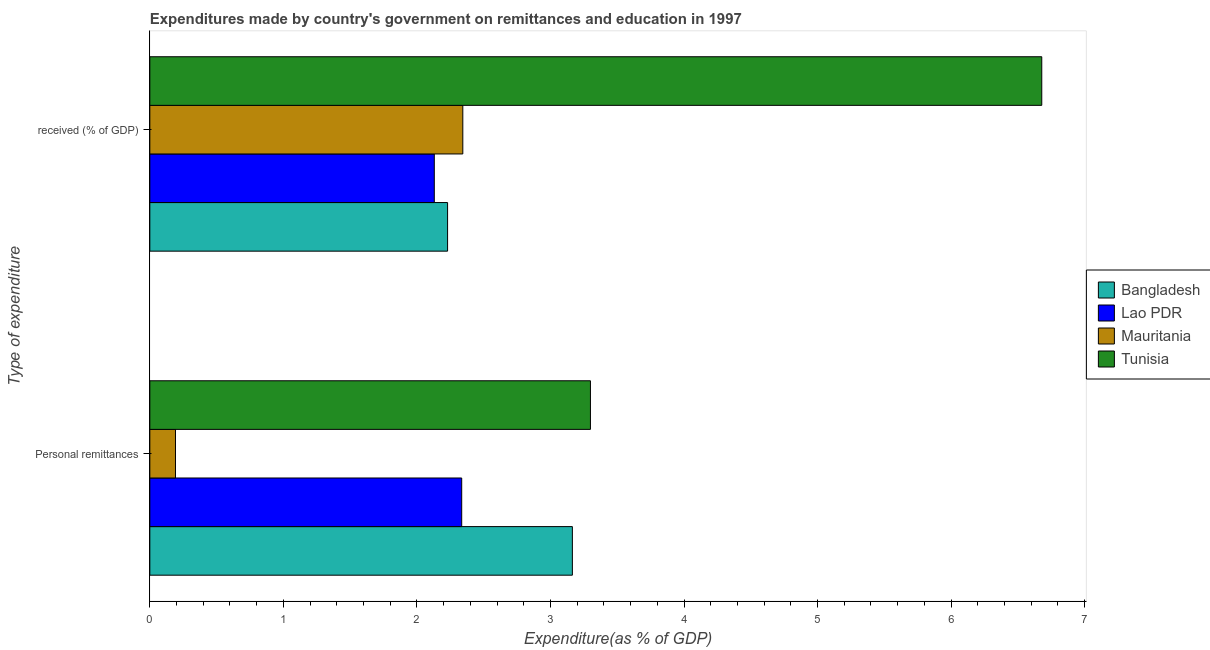Are the number of bars per tick equal to the number of legend labels?
Ensure brevity in your answer.  Yes. Are the number of bars on each tick of the Y-axis equal?
Your response must be concise. Yes. How many bars are there on the 2nd tick from the bottom?
Offer a very short reply. 4. What is the label of the 2nd group of bars from the top?
Offer a terse response. Personal remittances. What is the expenditure in education in Lao PDR?
Your response must be concise. 2.13. Across all countries, what is the maximum expenditure in personal remittances?
Make the answer very short. 3.3. Across all countries, what is the minimum expenditure in education?
Make the answer very short. 2.13. In which country was the expenditure in education maximum?
Provide a succinct answer. Tunisia. In which country was the expenditure in education minimum?
Your answer should be compact. Lao PDR. What is the total expenditure in education in the graph?
Ensure brevity in your answer.  13.38. What is the difference between the expenditure in education in Bangladesh and that in Mauritania?
Give a very brief answer. -0.11. What is the difference between the expenditure in personal remittances in Mauritania and the expenditure in education in Bangladesh?
Offer a terse response. -2.04. What is the average expenditure in education per country?
Offer a very short reply. 3.35. What is the difference between the expenditure in personal remittances and expenditure in education in Mauritania?
Provide a succinct answer. -2.15. What is the ratio of the expenditure in personal remittances in Tunisia to that in Mauritania?
Your answer should be compact. 17.17. Is the expenditure in education in Lao PDR less than that in Bangladesh?
Provide a succinct answer. Yes. In how many countries, is the expenditure in education greater than the average expenditure in education taken over all countries?
Your response must be concise. 1. What does the 2nd bar from the top in Personal remittances represents?
Your response must be concise. Mauritania. What does the 3rd bar from the bottom in  received (% of GDP) represents?
Provide a succinct answer. Mauritania. Are all the bars in the graph horizontal?
Ensure brevity in your answer.  Yes. How many countries are there in the graph?
Ensure brevity in your answer.  4. What is the difference between two consecutive major ticks on the X-axis?
Offer a terse response. 1. Does the graph contain any zero values?
Offer a very short reply. No. Does the graph contain grids?
Provide a succinct answer. No. Where does the legend appear in the graph?
Give a very brief answer. Center right. How are the legend labels stacked?
Your answer should be compact. Vertical. What is the title of the graph?
Provide a succinct answer. Expenditures made by country's government on remittances and education in 1997. What is the label or title of the X-axis?
Your answer should be compact. Expenditure(as % of GDP). What is the label or title of the Y-axis?
Provide a succinct answer. Type of expenditure. What is the Expenditure(as % of GDP) in Bangladesh in Personal remittances?
Offer a terse response. 3.16. What is the Expenditure(as % of GDP) of Lao PDR in Personal remittances?
Keep it short and to the point. 2.34. What is the Expenditure(as % of GDP) of Mauritania in Personal remittances?
Your answer should be compact. 0.19. What is the Expenditure(as % of GDP) of Tunisia in Personal remittances?
Provide a succinct answer. 3.3. What is the Expenditure(as % of GDP) of Bangladesh in  received (% of GDP)?
Provide a short and direct response. 2.23. What is the Expenditure(as % of GDP) of Lao PDR in  received (% of GDP)?
Offer a terse response. 2.13. What is the Expenditure(as % of GDP) of Mauritania in  received (% of GDP)?
Provide a succinct answer. 2.34. What is the Expenditure(as % of GDP) of Tunisia in  received (% of GDP)?
Your answer should be compact. 6.68. Across all Type of expenditure, what is the maximum Expenditure(as % of GDP) of Bangladesh?
Your answer should be compact. 3.16. Across all Type of expenditure, what is the maximum Expenditure(as % of GDP) of Lao PDR?
Your answer should be compact. 2.34. Across all Type of expenditure, what is the maximum Expenditure(as % of GDP) in Mauritania?
Make the answer very short. 2.34. Across all Type of expenditure, what is the maximum Expenditure(as % of GDP) of Tunisia?
Give a very brief answer. 6.68. Across all Type of expenditure, what is the minimum Expenditure(as % of GDP) in Bangladesh?
Make the answer very short. 2.23. Across all Type of expenditure, what is the minimum Expenditure(as % of GDP) in Lao PDR?
Offer a very short reply. 2.13. Across all Type of expenditure, what is the minimum Expenditure(as % of GDP) of Mauritania?
Offer a terse response. 0.19. Across all Type of expenditure, what is the minimum Expenditure(as % of GDP) in Tunisia?
Ensure brevity in your answer.  3.3. What is the total Expenditure(as % of GDP) of Bangladesh in the graph?
Offer a very short reply. 5.39. What is the total Expenditure(as % of GDP) in Lao PDR in the graph?
Provide a succinct answer. 4.47. What is the total Expenditure(as % of GDP) of Mauritania in the graph?
Your response must be concise. 2.54. What is the total Expenditure(as % of GDP) of Tunisia in the graph?
Offer a terse response. 9.98. What is the difference between the Expenditure(as % of GDP) of Bangladesh in Personal remittances and that in  received (% of GDP)?
Give a very brief answer. 0.93. What is the difference between the Expenditure(as % of GDP) of Lao PDR in Personal remittances and that in  received (% of GDP)?
Your response must be concise. 0.21. What is the difference between the Expenditure(as % of GDP) of Mauritania in Personal remittances and that in  received (% of GDP)?
Make the answer very short. -2.15. What is the difference between the Expenditure(as % of GDP) in Tunisia in Personal remittances and that in  received (% of GDP)?
Keep it short and to the point. -3.38. What is the difference between the Expenditure(as % of GDP) of Bangladesh in Personal remittances and the Expenditure(as % of GDP) of Lao PDR in  received (% of GDP)?
Your response must be concise. 1.03. What is the difference between the Expenditure(as % of GDP) in Bangladesh in Personal remittances and the Expenditure(as % of GDP) in Mauritania in  received (% of GDP)?
Offer a terse response. 0.82. What is the difference between the Expenditure(as % of GDP) in Bangladesh in Personal remittances and the Expenditure(as % of GDP) in Tunisia in  received (% of GDP)?
Provide a succinct answer. -3.51. What is the difference between the Expenditure(as % of GDP) of Lao PDR in Personal remittances and the Expenditure(as % of GDP) of Mauritania in  received (% of GDP)?
Provide a succinct answer. -0.01. What is the difference between the Expenditure(as % of GDP) in Lao PDR in Personal remittances and the Expenditure(as % of GDP) in Tunisia in  received (% of GDP)?
Provide a short and direct response. -4.34. What is the difference between the Expenditure(as % of GDP) of Mauritania in Personal remittances and the Expenditure(as % of GDP) of Tunisia in  received (% of GDP)?
Provide a succinct answer. -6.49. What is the average Expenditure(as % of GDP) of Bangladesh per Type of expenditure?
Give a very brief answer. 2.7. What is the average Expenditure(as % of GDP) of Lao PDR per Type of expenditure?
Offer a terse response. 2.23. What is the average Expenditure(as % of GDP) in Mauritania per Type of expenditure?
Keep it short and to the point. 1.27. What is the average Expenditure(as % of GDP) of Tunisia per Type of expenditure?
Give a very brief answer. 4.99. What is the difference between the Expenditure(as % of GDP) in Bangladesh and Expenditure(as % of GDP) in Lao PDR in Personal remittances?
Make the answer very short. 0.83. What is the difference between the Expenditure(as % of GDP) of Bangladesh and Expenditure(as % of GDP) of Mauritania in Personal remittances?
Provide a short and direct response. 2.97. What is the difference between the Expenditure(as % of GDP) of Bangladesh and Expenditure(as % of GDP) of Tunisia in Personal remittances?
Ensure brevity in your answer.  -0.14. What is the difference between the Expenditure(as % of GDP) of Lao PDR and Expenditure(as % of GDP) of Mauritania in Personal remittances?
Your answer should be compact. 2.14. What is the difference between the Expenditure(as % of GDP) of Lao PDR and Expenditure(as % of GDP) of Tunisia in Personal remittances?
Keep it short and to the point. -0.96. What is the difference between the Expenditure(as % of GDP) in Mauritania and Expenditure(as % of GDP) in Tunisia in Personal remittances?
Your answer should be very brief. -3.11. What is the difference between the Expenditure(as % of GDP) of Bangladesh and Expenditure(as % of GDP) of Lao PDR in  received (% of GDP)?
Offer a very short reply. 0.1. What is the difference between the Expenditure(as % of GDP) in Bangladesh and Expenditure(as % of GDP) in Mauritania in  received (% of GDP)?
Your answer should be very brief. -0.11. What is the difference between the Expenditure(as % of GDP) of Bangladesh and Expenditure(as % of GDP) of Tunisia in  received (% of GDP)?
Provide a succinct answer. -4.45. What is the difference between the Expenditure(as % of GDP) in Lao PDR and Expenditure(as % of GDP) in Mauritania in  received (% of GDP)?
Provide a short and direct response. -0.21. What is the difference between the Expenditure(as % of GDP) in Lao PDR and Expenditure(as % of GDP) in Tunisia in  received (% of GDP)?
Keep it short and to the point. -4.55. What is the difference between the Expenditure(as % of GDP) in Mauritania and Expenditure(as % of GDP) in Tunisia in  received (% of GDP)?
Your response must be concise. -4.34. What is the ratio of the Expenditure(as % of GDP) of Bangladesh in Personal remittances to that in  received (% of GDP)?
Make the answer very short. 1.42. What is the ratio of the Expenditure(as % of GDP) of Lao PDR in Personal remittances to that in  received (% of GDP)?
Offer a very short reply. 1.1. What is the ratio of the Expenditure(as % of GDP) of Mauritania in Personal remittances to that in  received (% of GDP)?
Give a very brief answer. 0.08. What is the ratio of the Expenditure(as % of GDP) in Tunisia in Personal remittances to that in  received (% of GDP)?
Keep it short and to the point. 0.49. What is the difference between the highest and the second highest Expenditure(as % of GDP) in Bangladesh?
Your answer should be compact. 0.93. What is the difference between the highest and the second highest Expenditure(as % of GDP) of Lao PDR?
Offer a very short reply. 0.21. What is the difference between the highest and the second highest Expenditure(as % of GDP) of Mauritania?
Give a very brief answer. 2.15. What is the difference between the highest and the second highest Expenditure(as % of GDP) of Tunisia?
Your response must be concise. 3.38. What is the difference between the highest and the lowest Expenditure(as % of GDP) in Bangladesh?
Give a very brief answer. 0.93. What is the difference between the highest and the lowest Expenditure(as % of GDP) of Lao PDR?
Keep it short and to the point. 0.21. What is the difference between the highest and the lowest Expenditure(as % of GDP) in Mauritania?
Offer a very short reply. 2.15. What is the difference between the highest and the lowest Expenditure(as % of GDP) of Tunisia?
Offer a terse response. 3.38. 